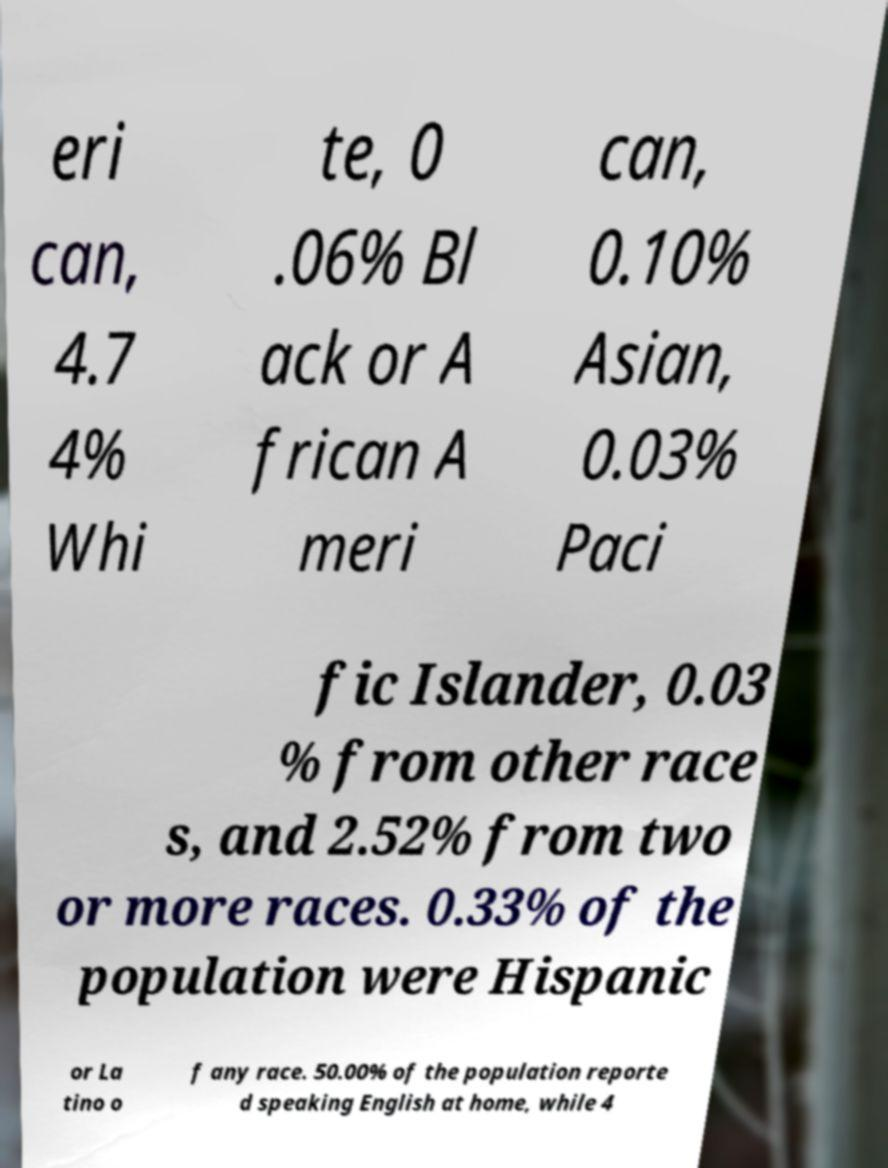There's text embedded in this image that I need extracted. Can you transcribe it verbatim? eri can, 4.7 4% Whi te, 0 .06% Bl ack or A frican A meri can, 0.10% Asian, 0.03% Paci fic Islander, 0.03 % from other race s, and 2.52% from two or more races. 0.33% of the population were Hispanic or La tino o f any race. 50.00% of the population reporte d speaking English at home, while 4 